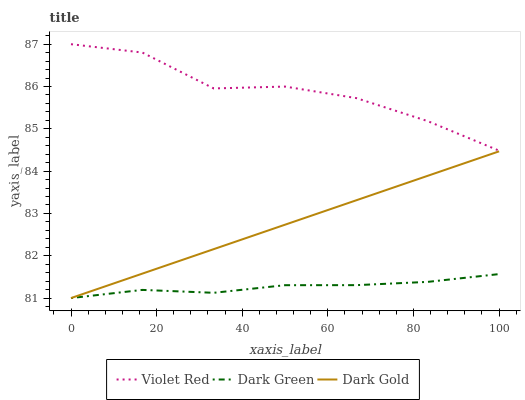Does Dark Green have the minimum area under the curve?
Answer yes or no. Yes. Does Violet Red have the maximum area under the curve?
Answer yes or no. Yes. Does Dark Gold have the minimum area under the curve?
Answer yes or no. No. Does Dark Gold have the maximum area under the curve?
Answer yes or no. No. Is Dark Gold the smoothest?
Answer yes or no. Yes. Is Violet Red the roughest?
Answer yes or no. Yes. Is Dark Green the smoothest?
Answer yes or no. No. Is Dark Green the roughest?
Answer yes or no. No. Does Dark Gold have the highest value?
Answer yes or no. No. Is Dark Gold less than Violet Red?
Answer yes or no. Yes. Is Violet Red greater than Dark Green?
Answer yes or no. Yes. Does Dark Gold intersect Violet Red?
Answer yes or no. No. 